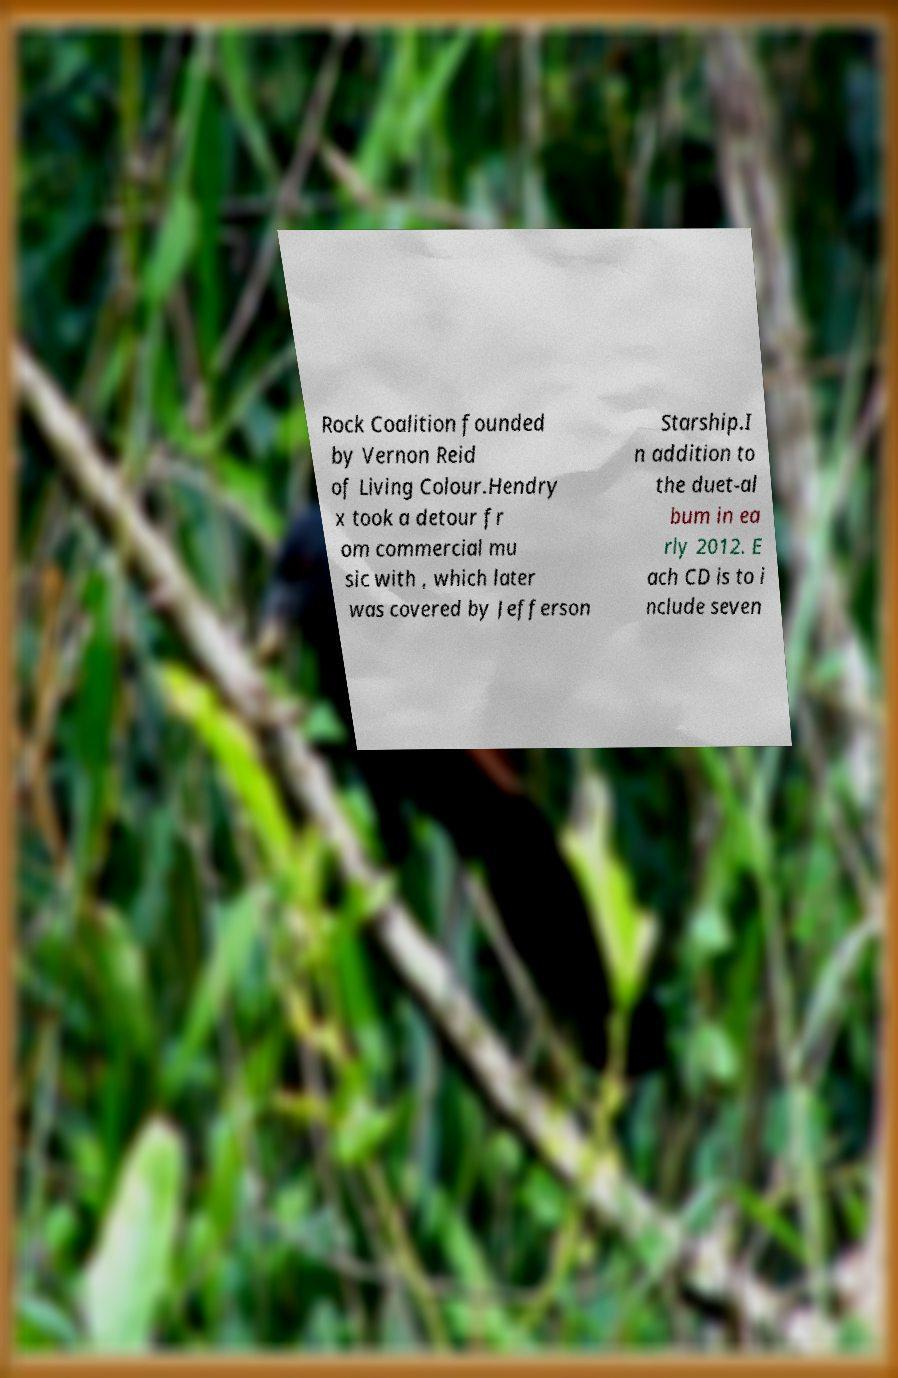Please identify and transcribe the text found in this image. Rock Coalition founded by Vernon Reid of Living Colour.Hendry x took a detour fr om commercial mu sic with , which later was covered by Jefferson Starship.I n addition to the duet-al bum in ea rly 2012. E ach CD is to i nclude seven 